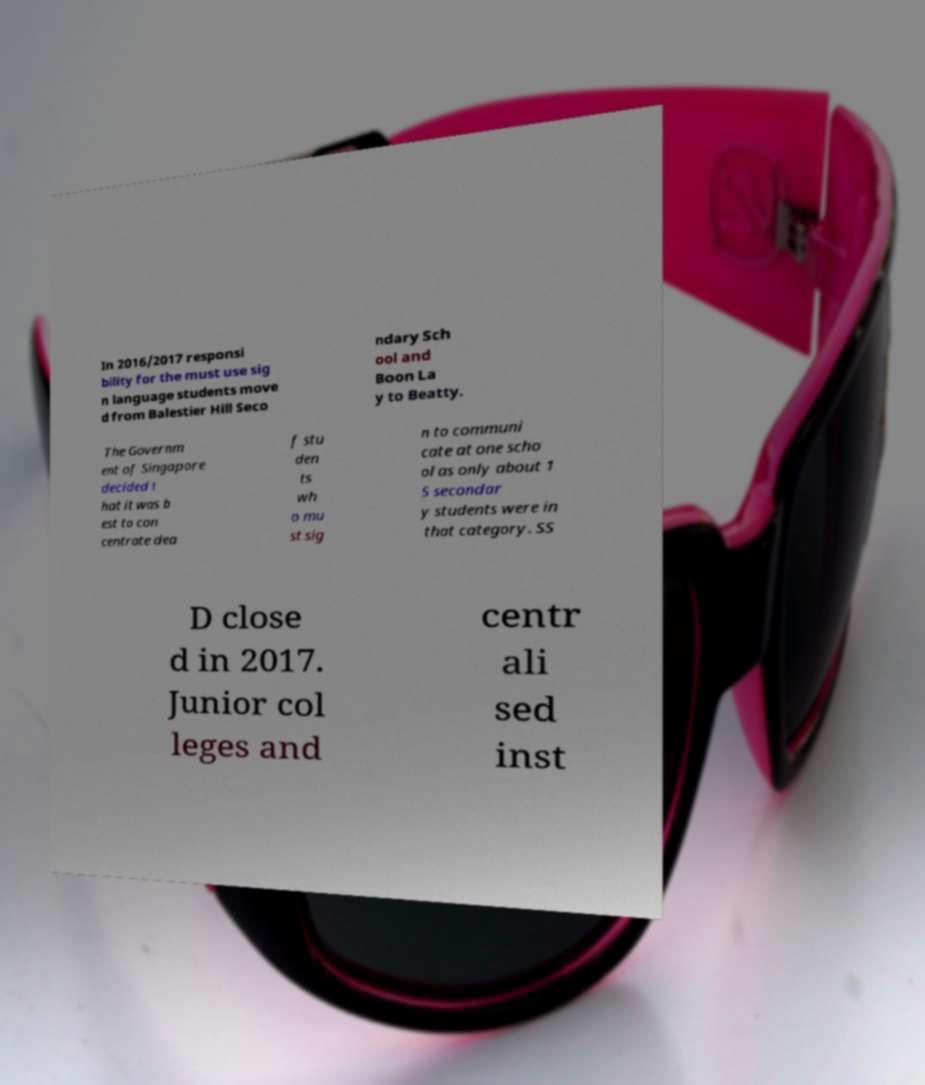Please identify and transcribe the text found in this image. In 2016/2017 responsi bility for the must use sig n language students move d from Balestier Hill Seco ndary Sch ool and Boon La y to Beatty. The Governm ent of Singapore decided t hat it was b est to con centrate dea f stu den ts wh o mu st sig n to communi cate at one scho ol as only about 1 5 secondar y students were in that category. SS D close d in 2017. Junior col leges and centr ali sed inst 